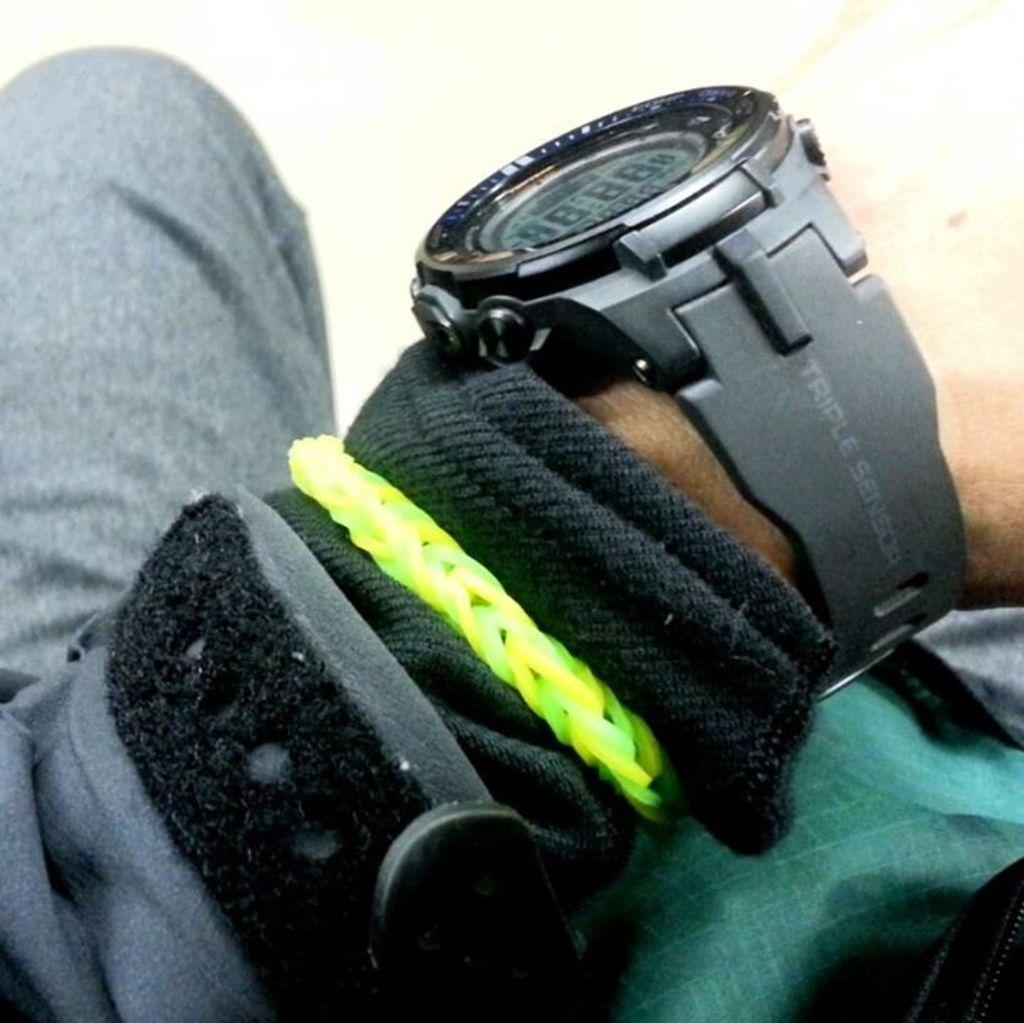<image>
Offer a succinct explanation of the picture presented. A person arm with triple sensor watch and some bracelets. 